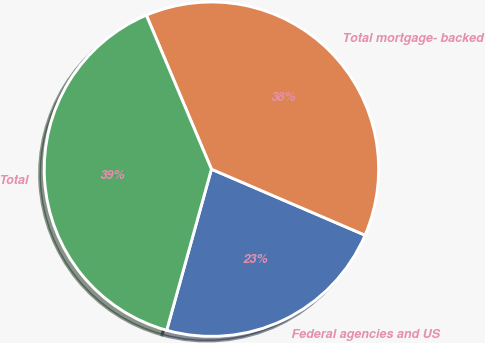Convert chart. <chart><loc_0><loc_0><loc_500><loc_500><pie_chart><fcel>Federal agencies and US<fcel>Total mortgage- backed<fcel>Total<nl><fcel>22.85%<fcel>37.82%<fcel>39.32%<nl></chart> 